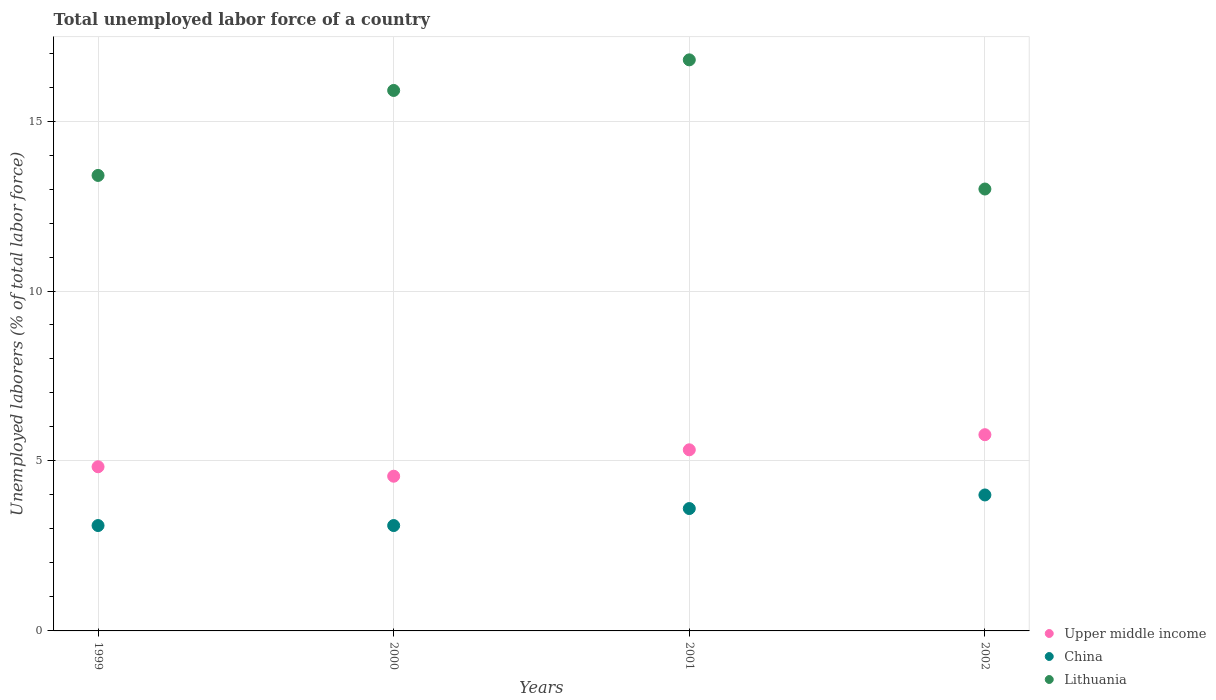How many different coloured dotlines are there?
Provide a succinct answer. 3. What is the total unemployed labor force in Upper middle income in 2002?
Keep it short and to the point. 5.77. Across all years, what is the maximum total unemployed labor force in Lithuania?
Ensure brevity in your answer.  16.8. Across all years, what is the minimum total unemployed labor force in China?
Offer a very short reply. 3.1. In which year was the total unemployed labor force in China maximum?
Provide a succinct answer. 2002. In which year was the total unemployed labor force in Lithuania minimum?
Make the answer very short. 2002. What is the total total unemployed labor force in China in the graph?
Your response must be concise. 13.8. What is the difference between the total unemployed labor force in Upper middle income in 1999 and that in 2002?
Offer a terse response. -0.94. What is the difference between the total unemployed labor force in Upper middle income in 2002 and the total unemployed labor force in China in 1999?
Give a very brief answer. 2.67. What is the average total unemployed labor force in Upper middle income per year?
Your answer should be compact. 5.12. In the year 1999, what is the difference between the total unemployed labor force in China and total unemployed labor force in Lithuania?
Ensure brevity in your answer.  -10.3. In how many years, is the total unemployed labor force in China greater than 15 %?
Provide a succinct answer. 0. What is the ratio of the total unemployed labor force in Lithuania in 2001 to that in 2002?
Give a very brief answer. 1.29. Is the difference between the total unemployed labor force in China in 2000 and 2002 greater than the difference between the total unemployed labor force in Lithuania in 2000 and 2002?
Offer a terse response. No. What is the difference between the highest and the second highest total unemployed labor force in Lithuania?
Your answer should be compact. 0.9. What is the difference between the highest and the lowest total unemployed labor force in China?
Keep it short and to the point. 0.9. In how many years, is the total unemployed labor force in Lithuania greater than the average total unemployed labor force in Lithuania taken over all years?
Keep it short and to the point. 2. Does the total unemployed labor force in Upper middle income monotonically increase over the years?
Your response must be concise. No. How many years are there in the graph?
Keep it short and to the point. 4. What is the difference between two consecutive major ticks on the Y-axis?
Offer a very short reply. 5. Are the values on the major ticks of Y-axis written in scientific E-notation?
Your answer should be very brief. No. Does the graph contain grids?
Offer a very short reply. Yes. How are the legend labels stacked?
Keep it short and to the point. Vertical. What is the title of the graph?
Make the answer very short. Total unemployed labor force of a country. What is the label or title of the Y-axis?
Ensure brevity in your answer.  Unemployed laborers (% of total labor force). What is the Unemployed laborers (% of total labor force) in Upper middle income in 1999?
Your response must be concise. 4.83. What is the Unemployed laborers (% of total labor force) in China in 1999?
Offer a very short reply. 3.1. What is the Unemployed laborers (% of total labor force) in Lithuania in 1999?
Keep it short and to the point. 13.4. What is the Unemployed laborers (% of total labor force) of Upper middle income in 2000?
Provide a short and direct response. 4.55. What is the Unemployed laborers (% of total labor force) in China in 2000?
Offer a very short reply. 3.1. What is the Unemployed laborers (% of total labor force) of Lithuania in 2000?
Your response must be concise. 15.9. What is the Unemployed laborers (% of total labor force) in Upper middle income in 2001?
Your answer should be very brief. 5.33. What is the Unemployed laborers (% of total labor force) in China in 2001?
Give a very brief answer. 3.6. What is the Unemployed laborers (% of total labor force) in Lithuania in 2001?
Offer a terse response. 16.8. What is the Unemployed laborers (% of total labor force) in Upper middle income in 2002?
Ensure brevity in your answer.  5.77. What is the Unemployed laborers (% of total labor force) of Lithuania in 2002?
Offer a very short reply. 13. Across all years, what is the maximum Unemployed laborers (% of total labor force) in Upper middle income?
Your answer should be compact. 5.77. Across all years, what is the maximum Unemployed laborers (% of total labor force) in Lithuania?
Your answer should be very brief. 16.8. Across all years, what is the minimum Unemployed laborers (% of total labor force) in Upper middle income?
Give a very brief answer. 4.55. Across all years, what is the minimum Unemployed laborers (% of total labor force) of China?
Keep it short and to the point. 3.1. What is the total Unemployed laborers (% of total labor force) of Upper middle income in the graph?
Give a very brief answer. 20.48. What is the total Unemployed laborers (% of total labor force) of Lithuania in the graph?
Make the answer very short. 59.1. What is the difference between the Unemployed laborers (% of total labor force) in Upper middle income in 1999 and that in 2000?
Offer a terse response. 0.28. What is the difference between the Unemployed laborers (% of total labor force) in China in 1999 and that in 2000?
Give a very brief answer. 0. What is the difference between the Unemployed laborers (% of total labor force) in Upper middle income in 1999 and that in 2001?
Provide a short and direct response. -0.5. What is the difference between the Unemployed laborers (% of total labor force) of China in 1999 and that in 2001?
Offer a terse response. -0.5. What is the difference between the Unemployed laborers (% of total labor force) in Upper middle income in 1999 and that in 2002?
Make the answer very short. -0.94. What is the difference between the Unemployed laborers (% of total labor force) in China in 1999 and that in 2002?
Make the answer very short. -0.9. What is the difference between the Unemployed laborers (% of total labor force) in Lithuania in 1999 and that in 2002?
Provide a short and direct response. 0.4. What is the difference between the Unemployed laborers (% of total labor force) of Upper middle income in 2000 and that in 2001?
Provide a succinct answer. -0.78. What is the difference between the Unemployed laborers (% of total labor force) of Upper middle income in 2000 and that in 2002?
Keep it short and to the point. -1.22. What is the difference between the Unemployed laborers (% of total labor force) of Lithuania in 2000 and that in 2002?
Provide a succinct answer. 2.9. What is the difference between the Unemployed laborers (% of total labor force) in Upper middle income in 2001 and that in 2002?
Offer a terse response. -0.44. What is the difference between the Unemployed laborers (% of total labor force) in Upper middle income in 1999 and the Unemployed laborers (% of total labor force) in China in 2000?
Your response must be concise. 1.73. What is the difference between the Unemployed laborers (% of total labor force) in Upper middle income in 1999 and the Unemployed laborers (% of total labor force) in Lithuania in 2000?
Give a very brief answer. -11.07. What is the difference between the Unemployed laborers (% of total labor force) in Upper middle income in 1999 and the Unemployed laborers (% of total labor force) in China in 2001?
Make the answer very short. 1.23. What is the difference between the Unemployed laborers (% of total labor force) in Upper middle income in 1999 and the Unemployed laborers (% of total labor force) in Lithuania in 2001?
Your answer should be compact. -11.97. What is the difference between the Unemployed laborers (% of total labor force) in China in 1999 and the Unemployed laborers (% of total labor force) in Lithuania in 2001?
Offer a terse response. -13.7. What is the difference between the Unemployed laborers (% of total labor force) of Upper middle income in 1999 and the Unemployed laborers (% of total labor force) of China in 2002?
Offer a terse response. 0.83. What is the difference between the Unemployed laborers (% of total labor force) of Upper middle income in 1999 and the Unemployed laborers (% of total labor force) of Lithuania in 2002?
Ensure brevity in your answer.  -8.17. What is the difference between the Unemployed laborers (% of total labor force) of Upper middle income in 2000 and the Unemployed laborers (% of total labor force) of China in 2001?
Give a very brief answer. 0.95. What is the difference between the Unemployed laborers (% of total labor force) of Upper middle income in 2000 and the Unemployed laborers (% of total labor force) of Lithuania in 2001?
Offer a terse response. -12.25. What is the difference between the Unemployed laborers (% of total labor force) of China in 2000 and the Unemployed laborers (% of total labor force) of Lithuania in 2001?
Keep it short and to the point. -13.7. What is the difference between the Unemployed laborers (% of total labor force) of Upper middle income in 2000 and the Unemployed laborers (% of total labor force) of China in 2002?
Your response must be concise. 0.55. What is the difference between the Unemployed laborers (% of total labor force) of Upper middle income in 2000 and the Unemployed laborers (% of total labor force) of Lithuania in 2002?
Your response must be concise. -8.45. What is the difference between the Unemployed laborers (% of total labor force) in China in 2000 and the Unemployed laborers (% of total labor force) in Lithuania in 2002?
Your answer should be compact. -9.9. What is the difference between the Unemployed laborers (% of total labor force) in Upper middle income in 2001 and the Unemployed laborers (% of total labor force) in China in 2002?
Offer a very short reply. 1.33. What is the difference between the Unemployed laborers (% of total labor force) of Upper middle income in 2001 and the Unemployed laborers (% of total labor force) of Lithuania in 2002?
Your answer should be very brief. -7.67. What is the difference between the Unemployed laborers (% of total labor force) of China in 2001 and the Unemployed laborers (% of total labor force) of Lithuania in 2002?
Provide a short and direct response. -9.4. What is the average Unemployed laborers (% of total labor force) of Upper middle income per year?
Your answer should be very brief. 5.12. What is the average Unemployed laborers (% of total labor force) in China per year?
Provide a succinct answer. 3.45. What is the average Unemployed laborers (% of total labor force) in Lithuania per year?
Ensure brevity in your answer.  14.78. In the year 1999, what is the difference between the Unemployed laborers (% of total labor force) in Upper middle income and Unemployed laborers (% of total labor force) in China?
Your answer should be compact. 1.73. In the year 1999, what is the difference between the Unemployed laborers (% of total labor force) in Upper middle income and Unemployed laborers (% of total labor force) in Lithuania?
Give a very brief answer. -8.57. In the year 2000, what is the difference between the Unemployed laborers (% of total labor force) in Upper middle income and Unemployed laborers (% of total labor force) in China?
Keep it short and to the point. 1.45. In the year 2000, what is the difference between the Unemployed laborers (% of total labor force) of Upper middle income and Unemployed laborers (% of total labor force) of Lithuania?
Keep it short and to the point. -11.35. In the year 2000, what is the difference between the Unemployed laborers (% of total labor force) of China and Unemployed laborers (% of total labor force) of Lithuania?
Offer a terse response. -12.8. In the year 2001, what is the difference between the Unemployed laborers (% of total labor force) in Upper middle income and Unemployed laborers (% of total labor force) in China?
Your answer should be very brief. 1.73. In the year 2001, what is the difference between the Unemployed laborers (% of total labor force) in Upper middle income and Unemployed laborers (% of total labor force) in Lithuania?
Make the answer very short. -11.47. In the year 2002, what is the difference between the Unemployed laborers (% of total labor force) in Upper middle income and Unemployed laborers (% of total labor force) in China?
Provide a short and direct response. 1.77. In the year 2002, what is the difference between the Unemployed laborers (% of total labor force) in Upper middle income and Unemployed laborers (% of total labor force) in Lithuania?
Your answer should be very brief. -7.23. In the year 2002, what is the difference between the Unemployed laborers (% of total labor force) in China and Unemployed laborers (% of total labor force) in Lithuania?
Provide a succinct answer. -9. What is the ratio of the Unemployed laborers (% of total labor force) of Upper middle income in 1999 to that in 2000?
Your answer should be compact. 1.06. What is the ratio of the Unemployed laborers (% of total labor force) of Lithuania in 1999 to that in 2000?
Ensure brevity in your answer.  0.84. What is the ratio of the Unemployed laborers (% of total labor force) in Upper middle income in 1999 to that in 2001?
Offer a very short reply. 0.91. What is the ratio of the Unemployed laborers (% of total labor force) of China in 1999 to that in 2001?
Give a very brief answer. 0.86. What is the ratio of the Unemployed laborers (% of total labor force) of Lithuania in 1999 to that in 2001?
Your answer should be compact. 0.8. What is the ratio of the Unemployed laborers (% of total labor force) in Upper middle income in 1999 to that in 2002?
Provide a succinct answer. 0.84. What is the ratio of the Unemployed laborers (% of total labor force) of China in 1999 to that in 2002?
Offer a very short reply. 0.78. What is the ratio of the Unemployed laborers (% of total labor force) of Lithuania in 1999 to that in 2002?
Provide a short and direct response. 1.03. What is the ratio of the Unemployed laborers (% of total labor force) in Upper middle income in 2000 to that in 2001?
Your answer should be compact. 0.85. What is the ratio of the Unemployed laborers (% of total labor force) in China in 2000 to that in 2001?
Offer a terse response. 0.86. What is the ratio of the Unemployed laborers (% of total labor force) of Lithuania in 2000 to that in 2001?
Give a very brief answer. 0.95. What is the ratio of the Unemployed laborers (% of total labor force) of Upper middle income in 2000 to that in 2002?
Ensure brevity in your answer.  0.79. What is the ratio of the Unemployed laborers (% of total labor force) of China in 2000 to that in 2002?
Make the answer very short. 0.78. What is the ratio of the Unemployed laborers (% of total labor force) of Lithuania in 2000 to that in 2002?
Your answer should be very brief. 1.22. What is the ratio of the Unemployed laborers (% of total labor force) in Upper middle income in 2001 to that in 2002?
Ensure brevity in your answer.  0.92. What is the ratio of the Unemployed laborers (% of total labor force) in Lithuania in 2001 to that in 2002?
Make the answer very short. 1.29. What is the difference between the highest and the second highest Unemployed laborers (% of total labor force) in Upper middle income?
Keep it short and to the point. 0.44. What is the difference between the highest and the second highest Unemployed laborers (% of total labor force) of Lithuania?
Offer a very short reply. 0.9. What is the difference between the highest and the lowest Unemployed laborers (% of total labor force) of Upper middle income?
Your answer should be compact. 1.22. What is the difference between the highest and the lowest Unemployed laborers (% of total labor force) of China?
Keep it short and to the point. 0.9. 